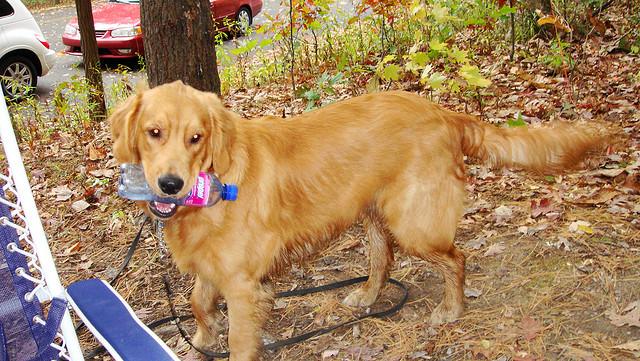Is there a chair in the image?
Write a very short answer. Yes. What kind of dog breed is shown?
Be succinct. Golden retriever. What toy does this dog have?
Short answer required. Bottle. 